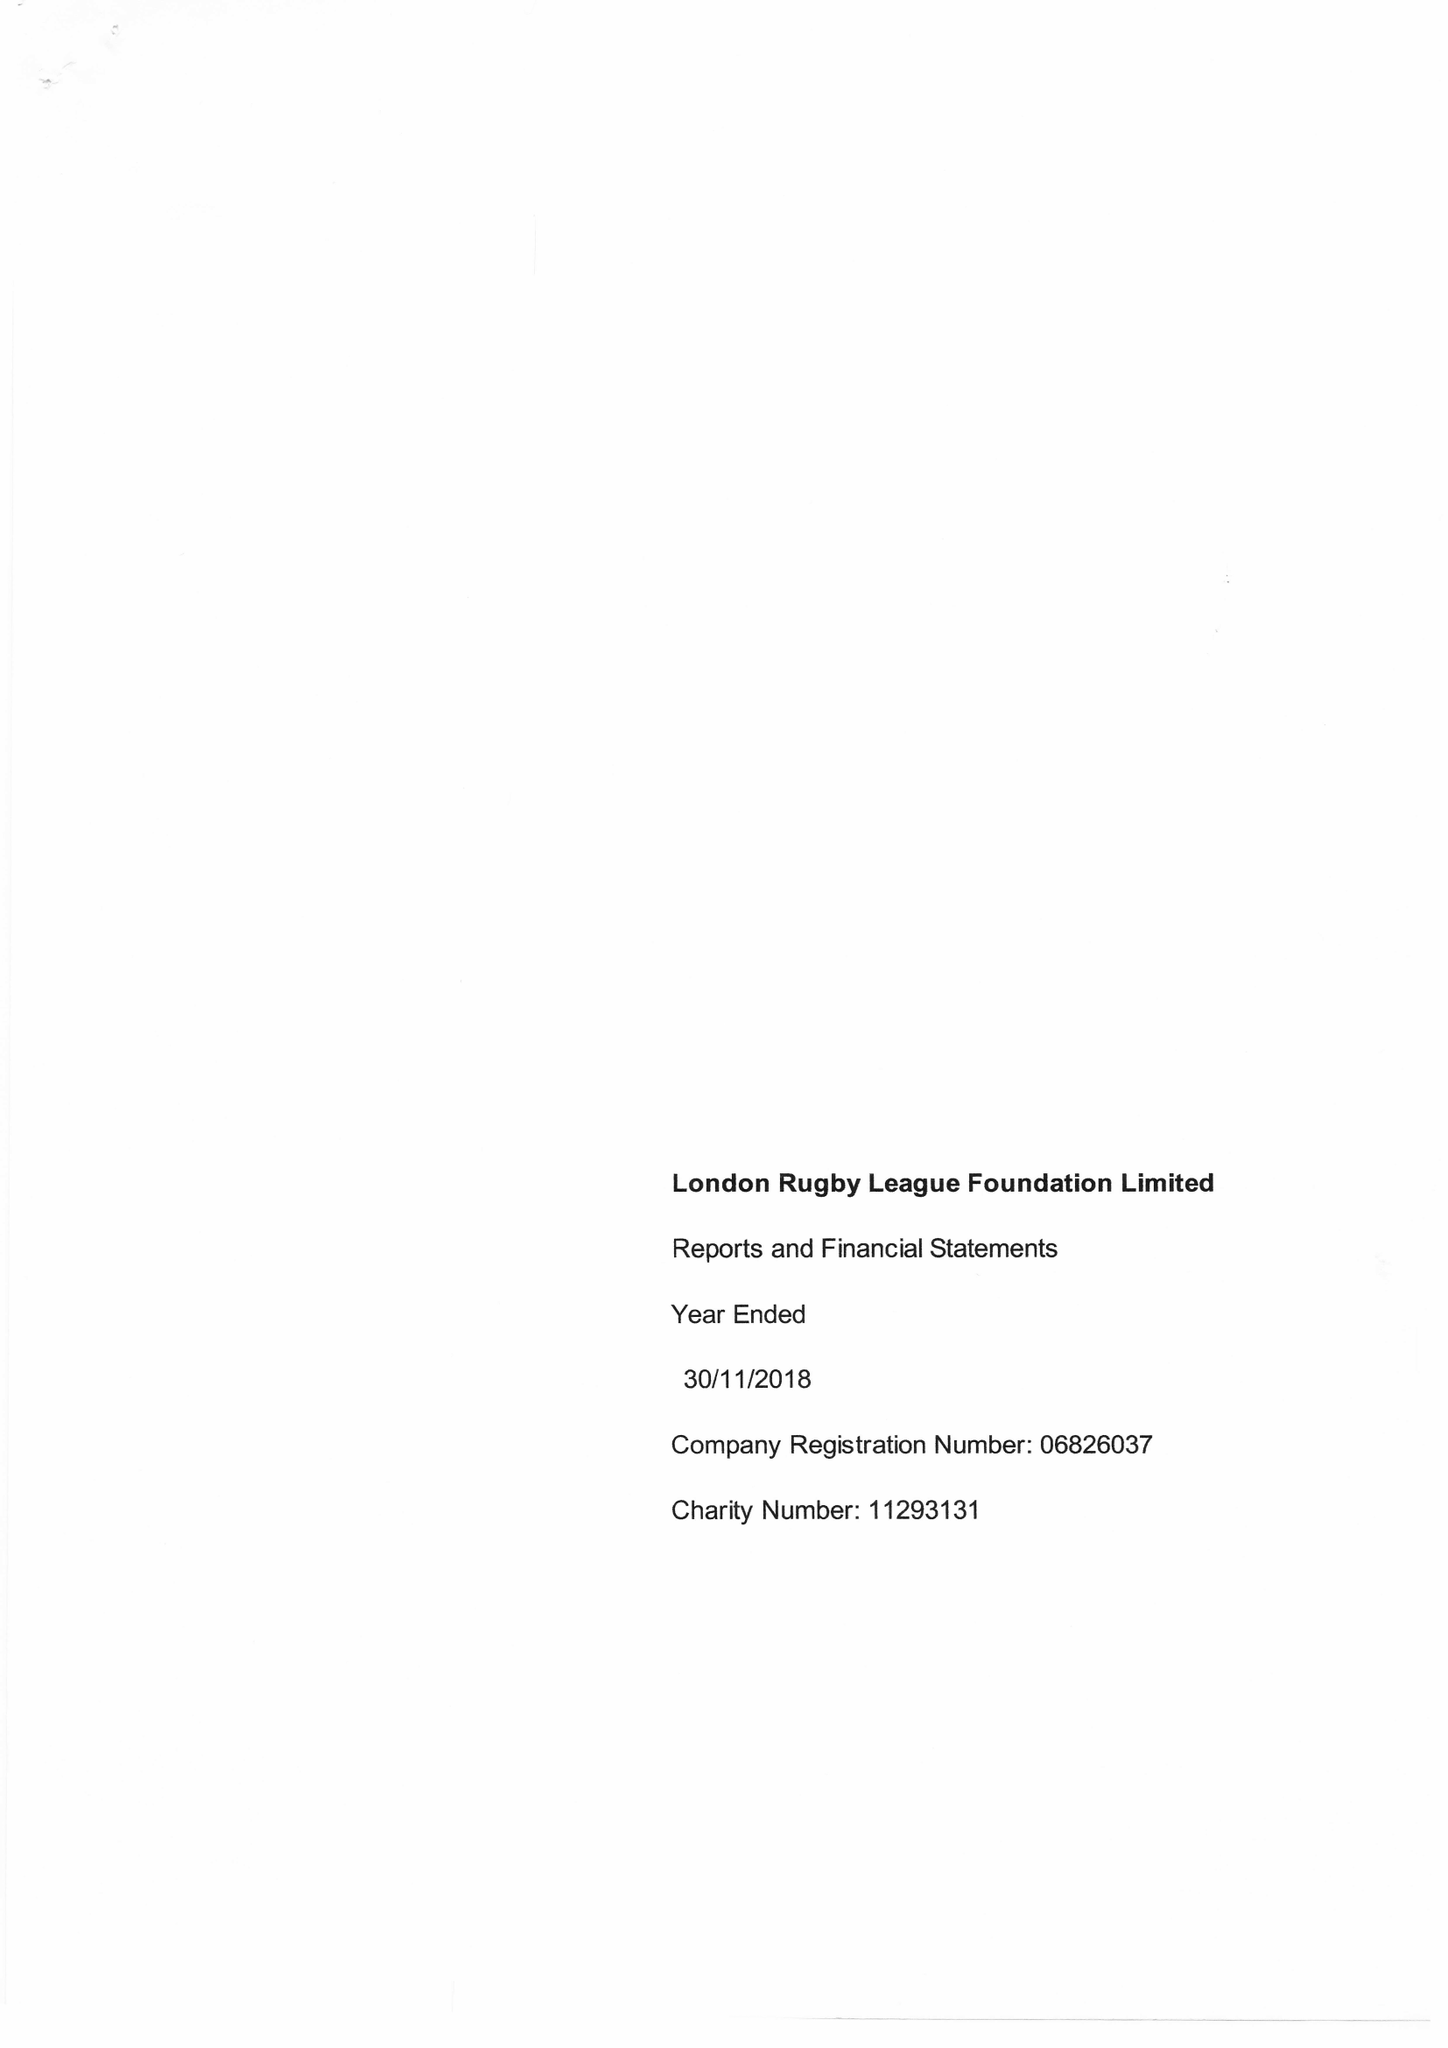What is the value for the report_date?
Answer the question using a single word or phrase. 2018-11-30 